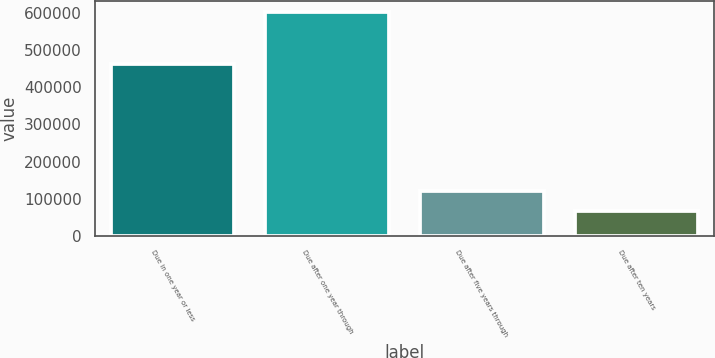Convert chart. <chart><loc_0><loc_0><loc_500><loc_500><bar_chart><fcel>Due in one year or less<fcel>Due after one year through<fcel>Due after five years through<fcel>Due after ten years<nl><fcel>463013<fcel>602105<fcel>120430<fcel>66910<nl></chart> 